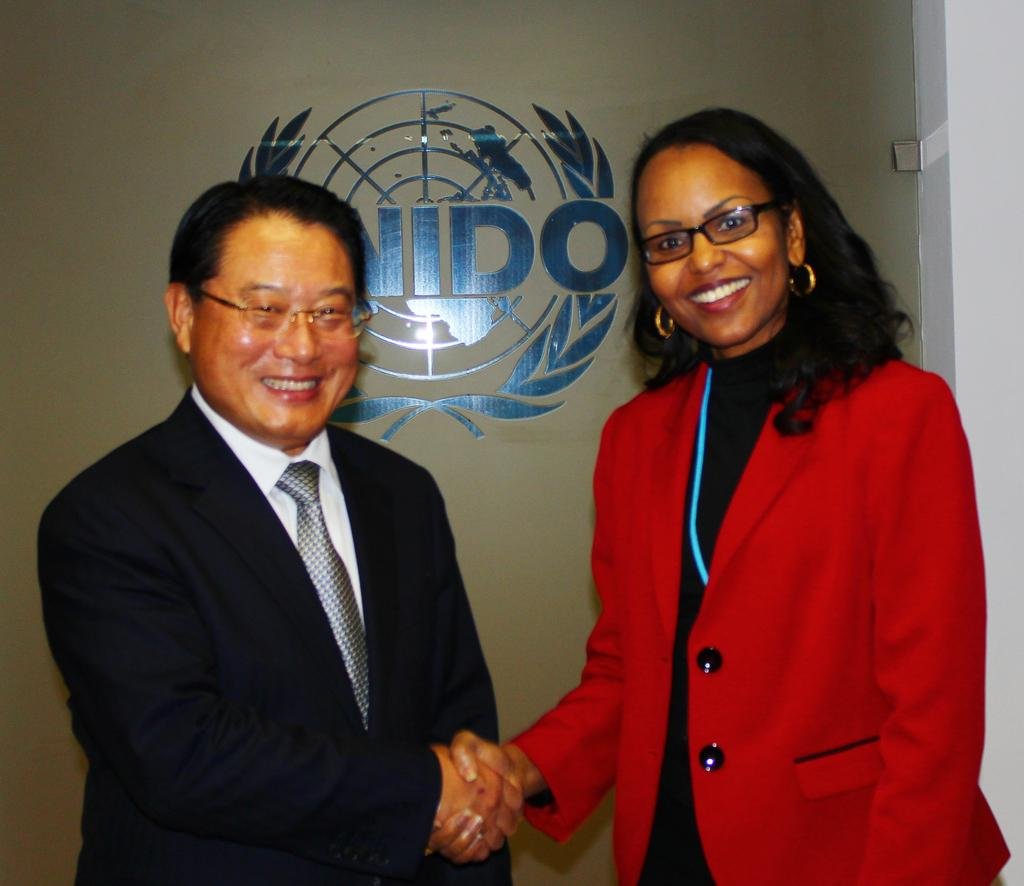What are the people in the image doing? The persons in the front of the image are standing, smiling, and shaking hands with each other. Can you describe the expressions on their faces? The persons are smiling in the image. What is visible in the background of the image? There is a wall in the background of the image. What is written on the wall? There is text written on the wall. What type of beetle can be seen crawling on the wall in the image? There is no beetle present in the image; only the persons and the wall with text are visible. 